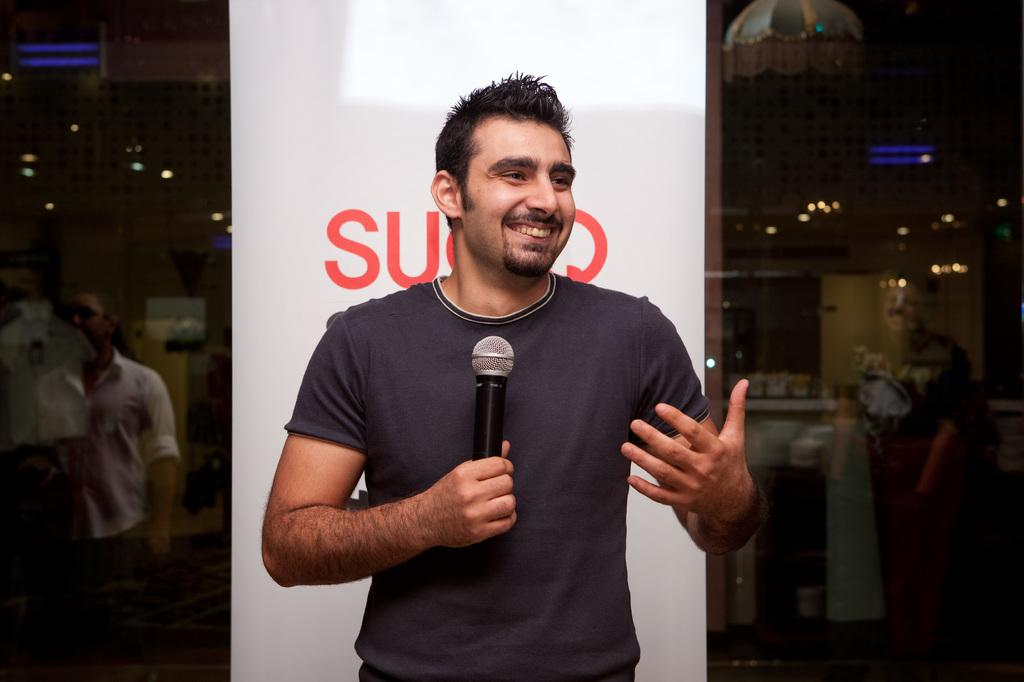Who is the main subject in the image? There is a man in the image. What is the man doing in the image? The man is standing behind a banner and holding a microphone. What type of truck is visible in the image? There is no truck present in the image. Is there any blood visible in the image? There is no blood present in the image. 